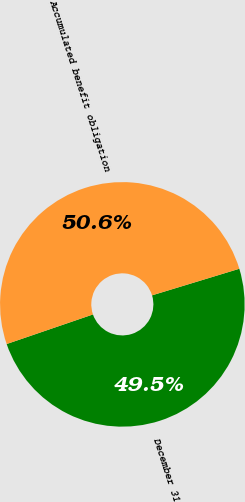Convert chart to OTSL. <chart><loc_0><loc_0><loc_500><loc_500><pie_chart><fcel>December 31<fcel>Accumulated benefit obligation<nl><fcel>49.45%<fcel>50.55%<nl></chart> 